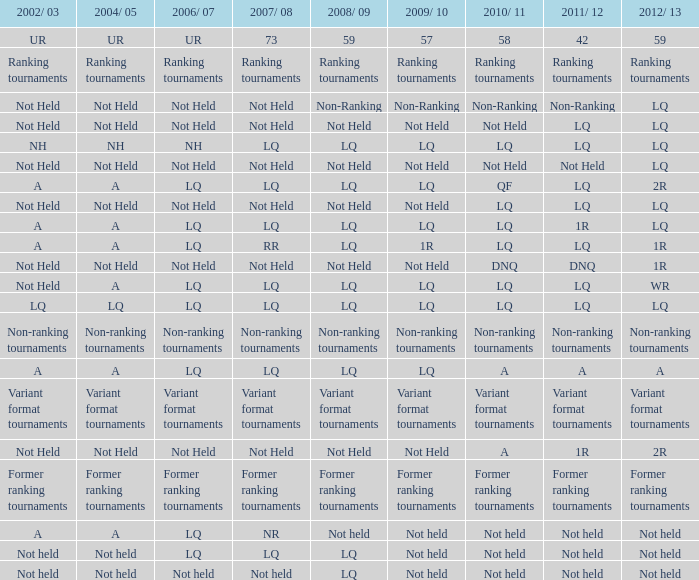Can you mention the circumstances in 2011/12 and 2008/09 when no events took place, in contrast to the 2010/11 period when there were also no events held? LQ, Not Held, Not held. 